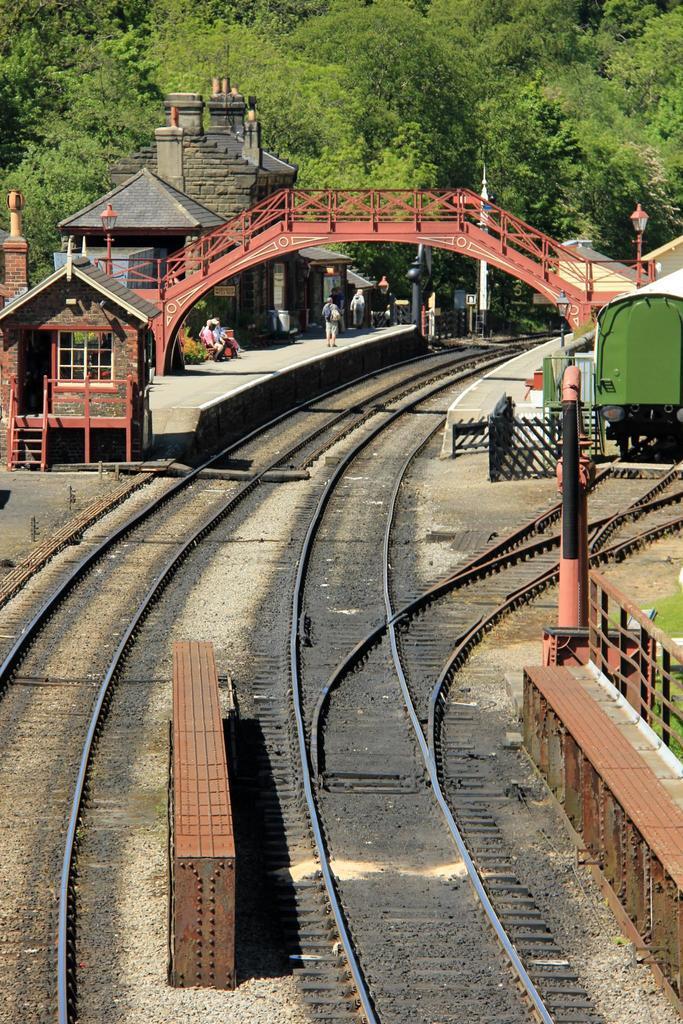Can you describe this image briefly? This image we can see railway tracks, bridge, platform. To the right side of the image there is a train. In the background of the image there are trees. 